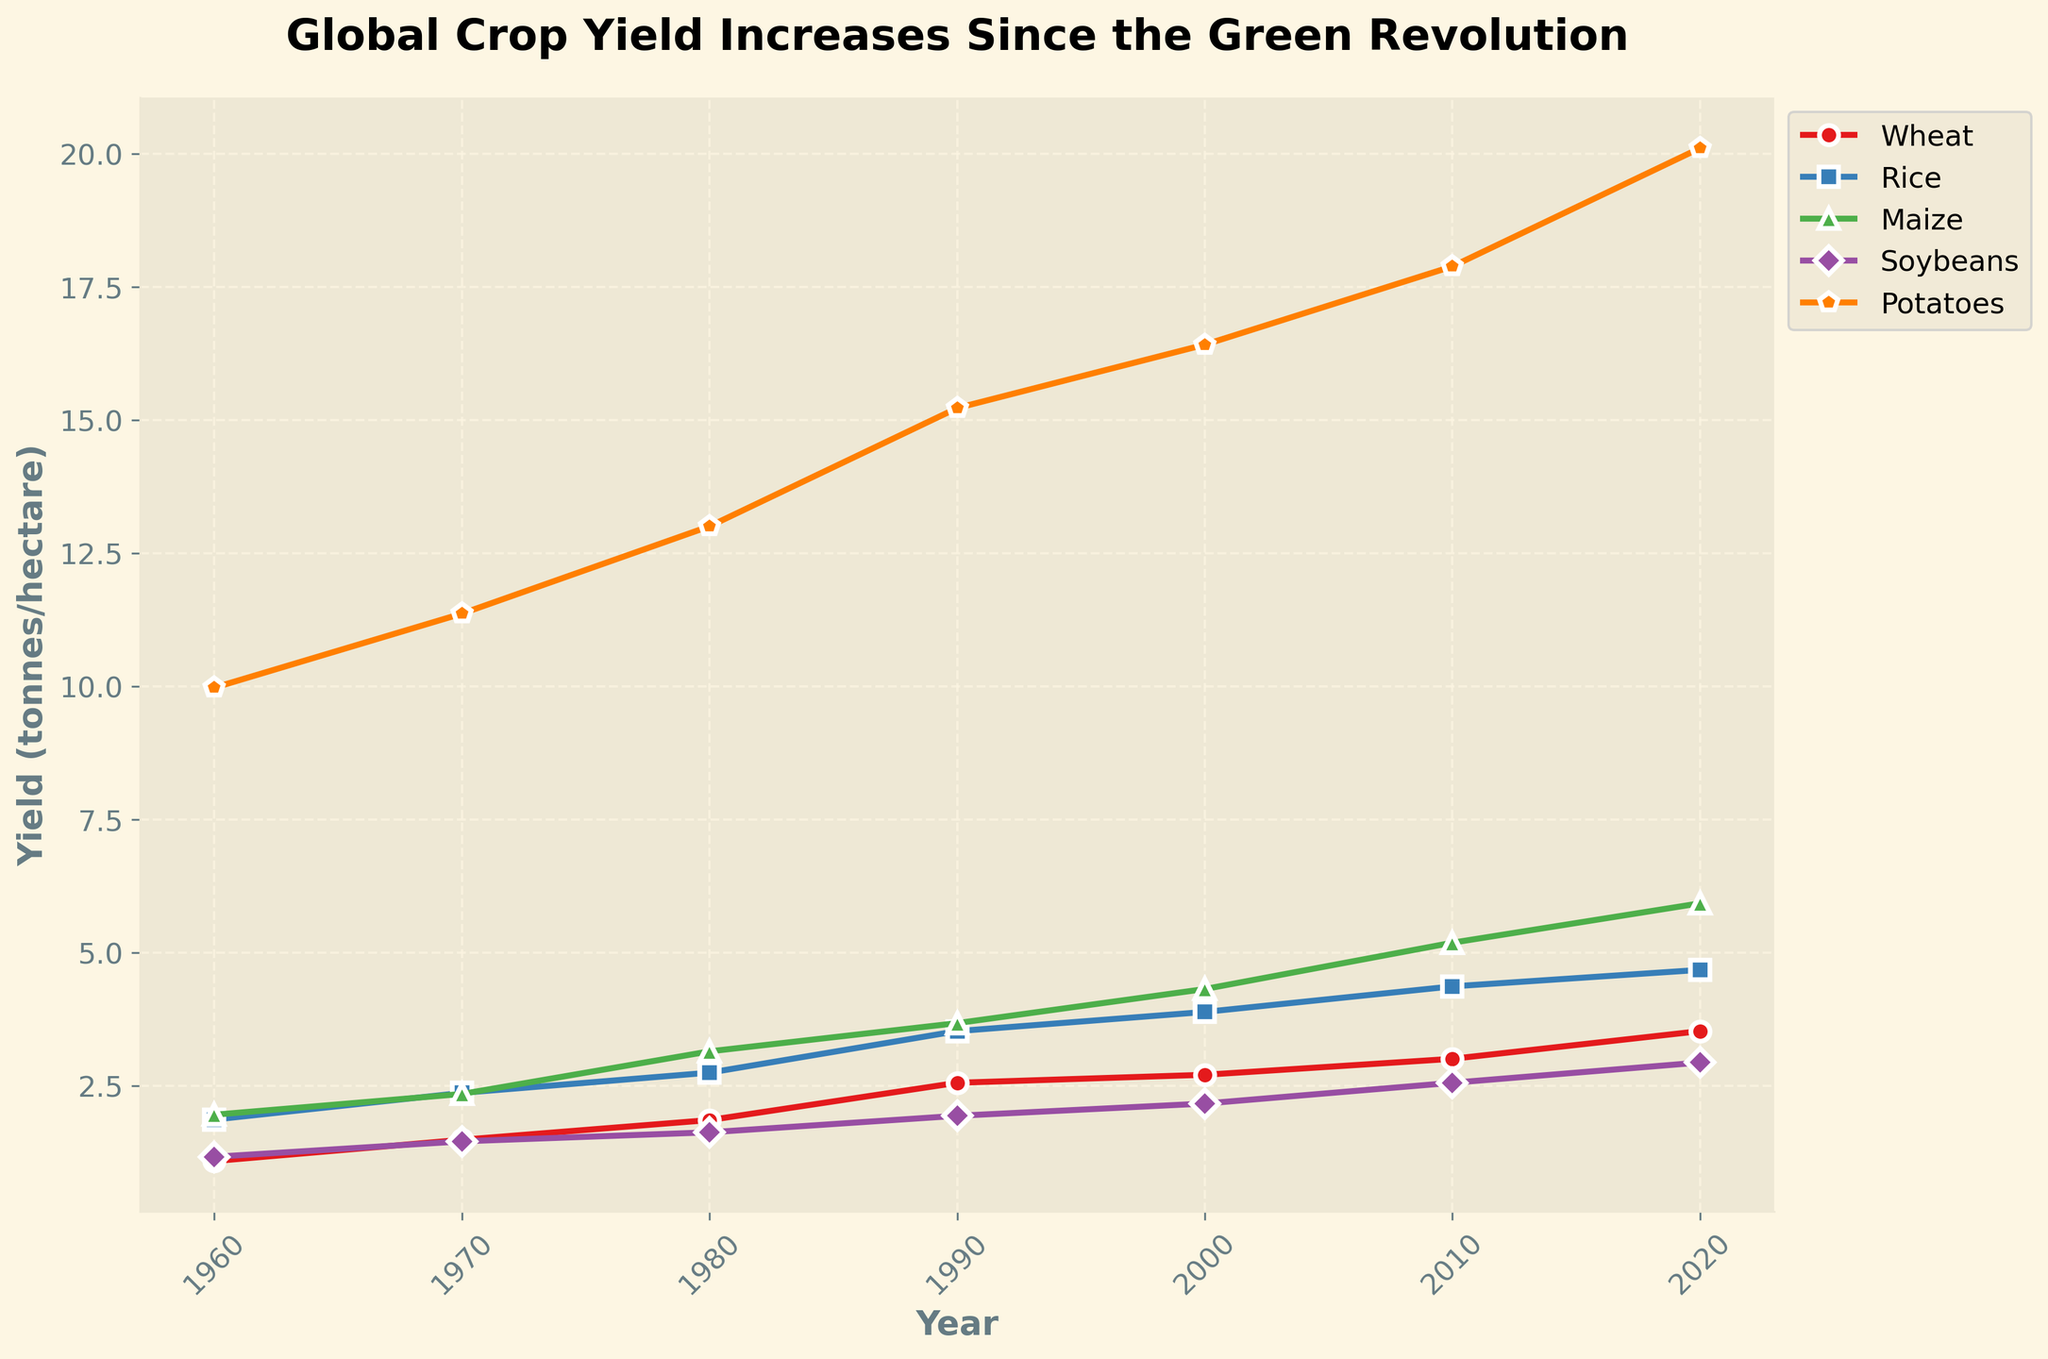What was the yield of rice in 1980? Look at the line for rice (blue color) and find the point corresponding to the year 1980, then read the y-axis value.
Answer: 2.75 Which crop had the highest yield in 2020? Look at the endpoints of all the crop lines in the year 2020 and compare their y-axis values.
Answer: Potatoes Which crop showed the most significant increase in yield from 1960 to 2020? Calculate the difference in yield from 1960 to 2020 for each crop. Wheat: 3.53 - 1.09 = 2.44, Rice: 4.68 - 1.87 = 2.81, Maize: 5.93 - 1.96 = 3.97, Soybeans: 2.94 - 1.17 = 1.77, Potatoes: 20.11 - 9.98 = 10.13. Potatoes had the highest increase.
Answer: Potatoes Between which years did maize see the largest yield increase? Compare the differences between consecutive years for maize. 1960-70: 2.35 - 1.96 = 0.39, 1970-80: 3.15 - 2.35 = 0.80, 1980-90: 3.68 - 3.15 = 0.53, 1990-2000: 4.32 - 3.68 = 0.64, 2000-10: 5.19 - 4.32 = 0.87, 2010-20: 5.93 - 5.19 = 0.74. The largest increase is between 2000 and 2010.
Answer: 2000-2010 What is the average yield of soybeans between 1960 and 2020? Sum the yields of soybeans for all years and divide by the number of years. (1.17 + 1.46 + 1.63 + 1.94 + 2.17 + 2.56 + 2.94) / 7 = 13.87 / 7 = 1.98.
Answer: 1.98 How did potato yields change visually over time? Describe the trajectory of the line representing potato yields, noting its slope and any changes in the gradient.
Answer: Gradually increasing with slight acceleration Among the crops, which had the least increase in yield from 1960 to 2020? Calculate the difference in yield from 1960 to 2020 for each crop, then find the smallest increase. Wheat: 3.53 - 1.09 = 2.44, Rice: 4.68 - 1.87 = 2.81, Maize: 5.93 - 1.96 = 3.97, Soybeans: 2.94 - 1.17 = 1.77, Potatoes: 20.11 - 9.98 = 10.13. Soybeans had the smallest increase.
Answer: Soybeans 